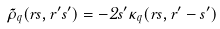Convert formula to latex. <formula><loc_0><loc_0><loc_500><loc_500>\tilde { \rho } _ { q } ( r s , r ^ { \prime } s ^ { \prime } ) = - 2 s ^ { \prime } \kappa _ { q } ( r s , r ^ { \prime } - s ^ { \prime } )</formula> 